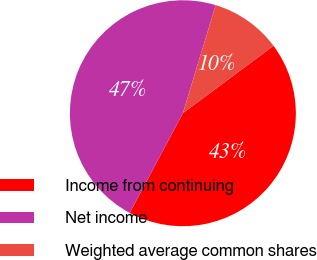Convert chart. <chart><loc_0><loc_0><loc_500><loc_500><pie_chart><fcel>Income from continuing<fcel>Net income<fcel>Weighted average common shares<nl><fcel>42.98%<fcel>46.9%<fcel>10.13%<nl></chart> 